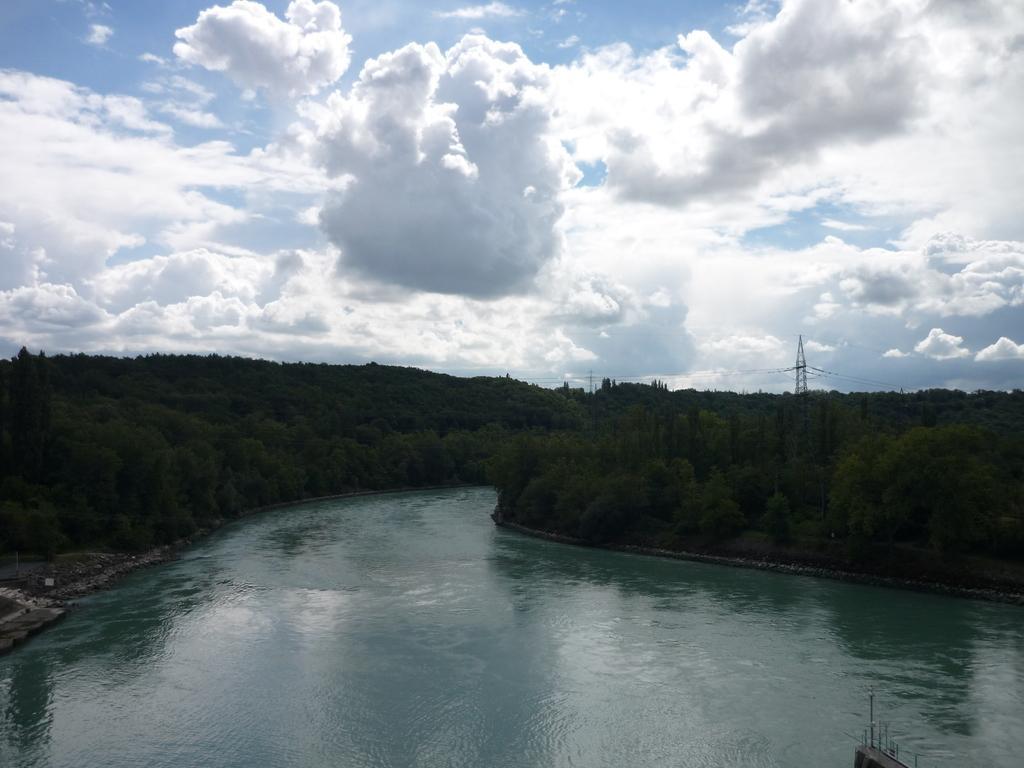Can you describe this image briefly? In this image in the foreground I can see the water, in the middle there are many trees and the background there is the sky. 